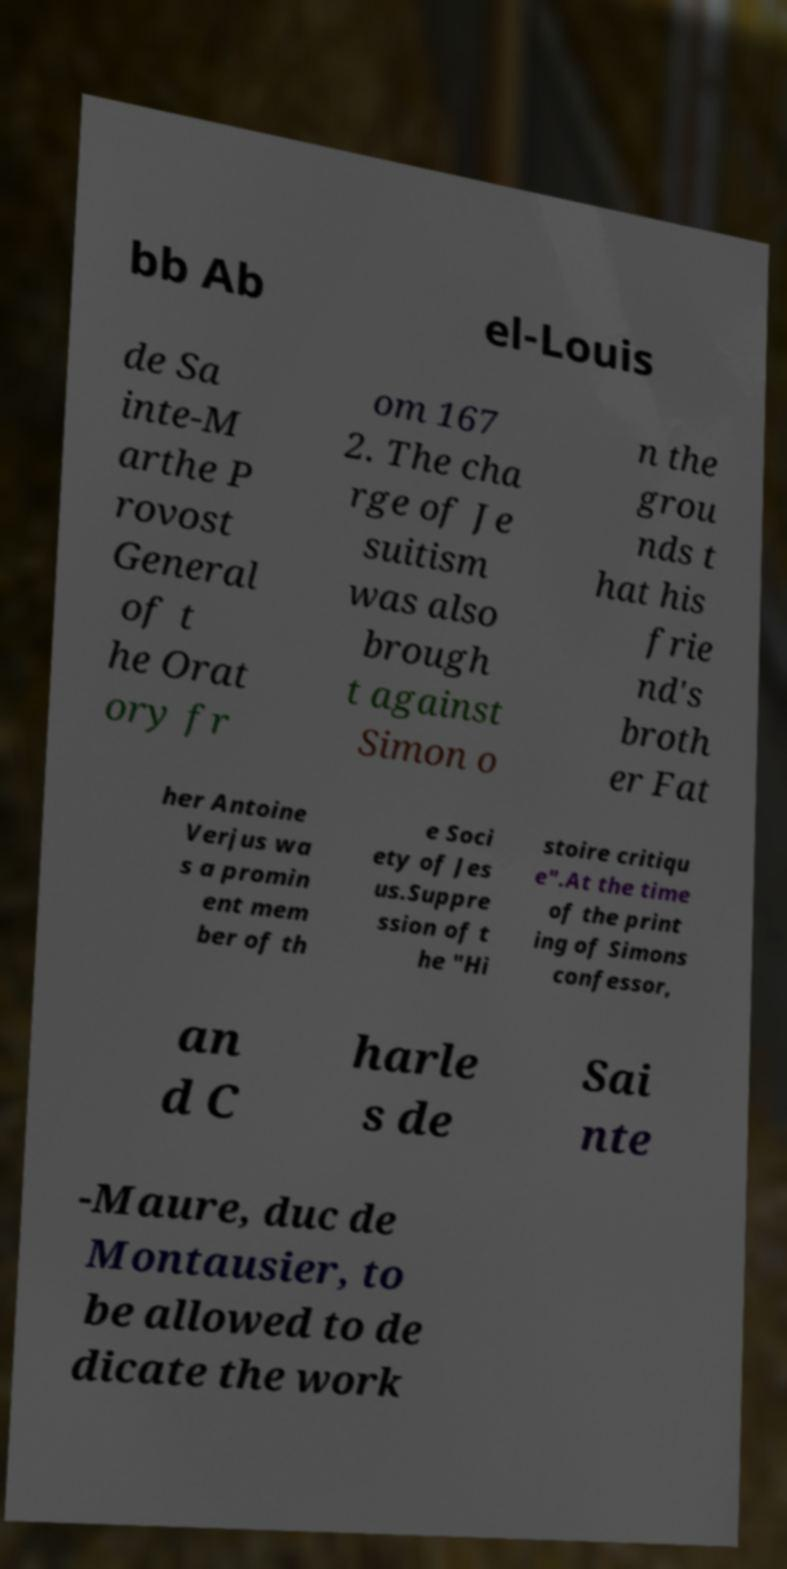Please read and relay the text visible in this image. What does it say? bb Ab el-Louis de Sa inte-M arthe P rovost General of t he Orat ory fr om 167 2. The cha rge of Je suitism was also brough t against Simon o n the grou nds t hat his frie nd's broth er Fat her Antoine Verjus wa s a promin ent mem ber of th e Soci ety of Jes us.Suppre ssion of t he "Hi stoire critiqu e".At the time of the print ing of Simons confessor, an d C harle s de Sai nte -Maure, duc de Montausier, to be allowed to de dicate the work 